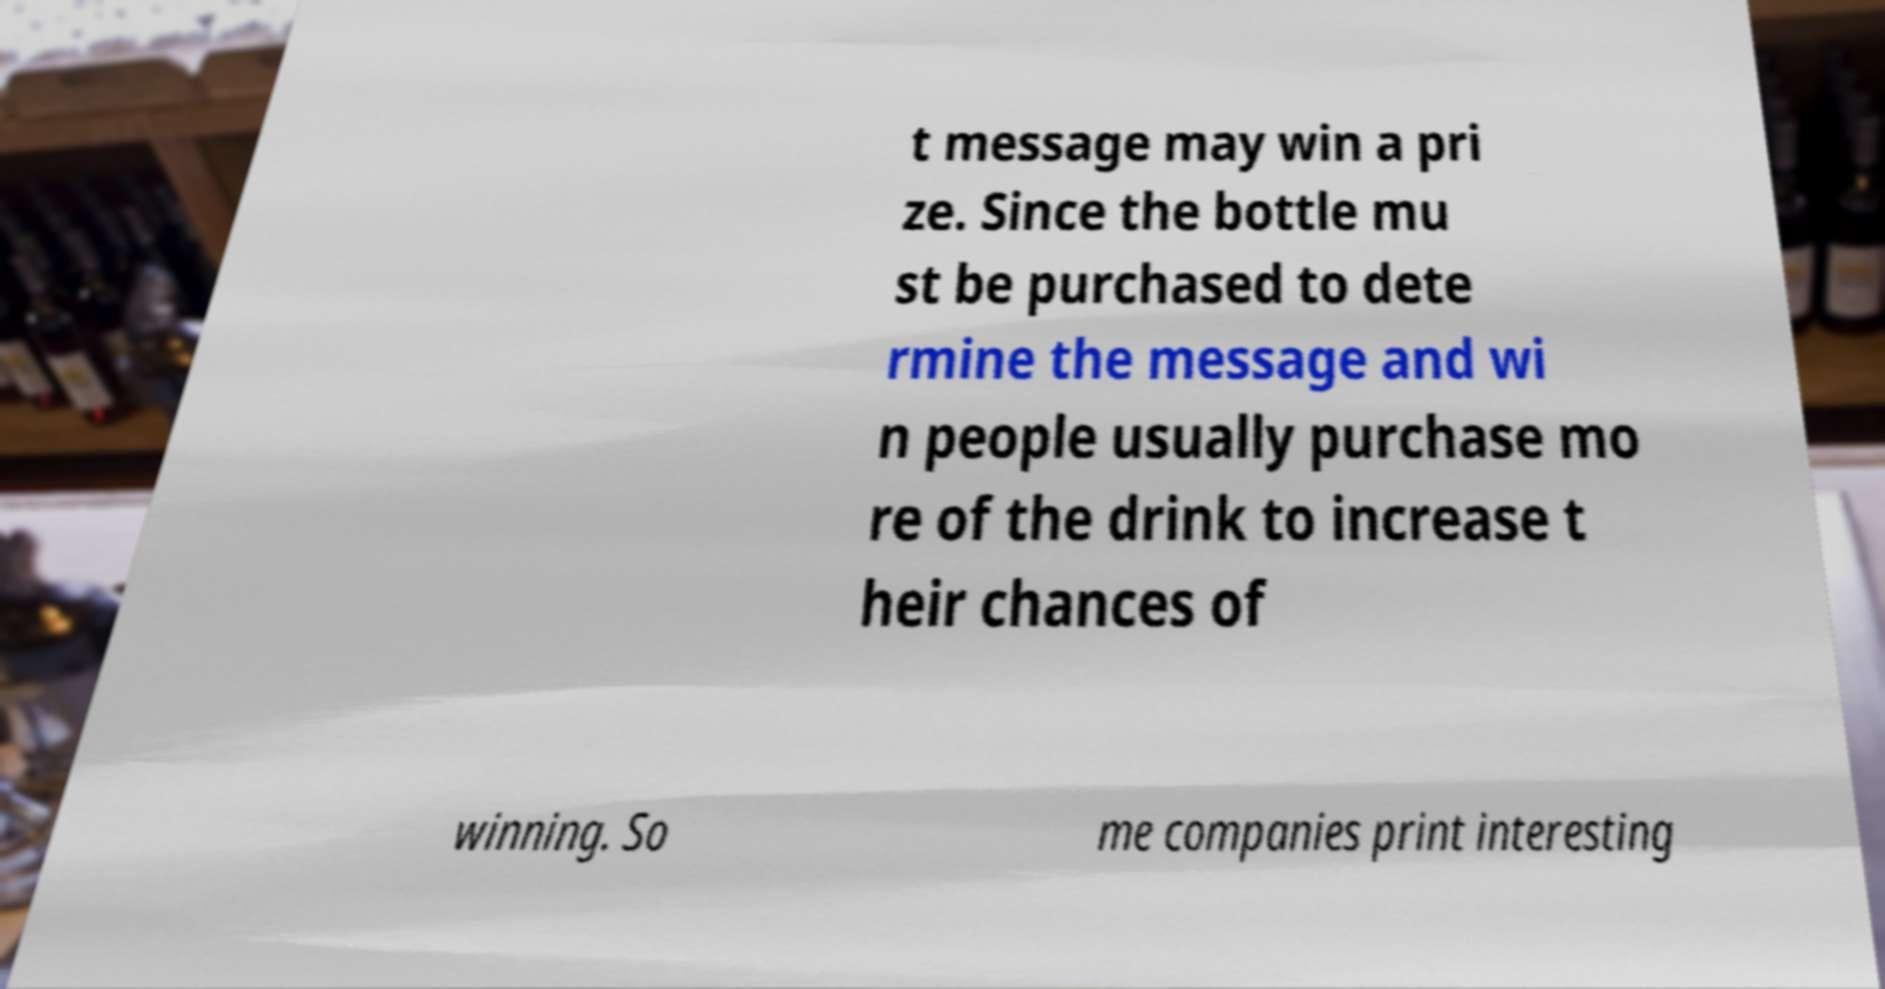There's text embedded in this image that I need extracted. Can you transcribe it verbatim? t message may win a pri ze. Since the bottle mu st be purchased to dete rmine the message and wi n people usually purchase mo re of the drink to increase t heir chances of winning. So me companies print interesting 